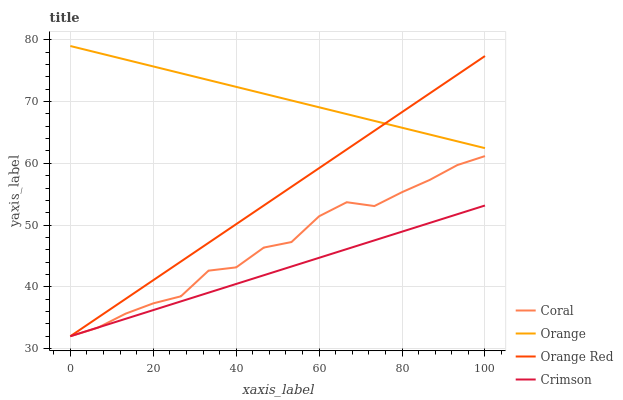Does Coral have the minimum area under the curve?
Answer yes or no. No. Does Coral have the maximum area under the curve?
Answer yes or no. No. Is Coral the smoothest?
Answer yes or no. No. Is Crimson the roughest?
Answer yes or no. No. Does Coral have the highest value?
Answer yes or no. No. Is Crimson less than Orange?
Answer yes or no. Yes. Is Orange greater than Crimson?
Answer yes or no. Yes. Does Crimson intersect Orange?
Answer yes or no. No. 